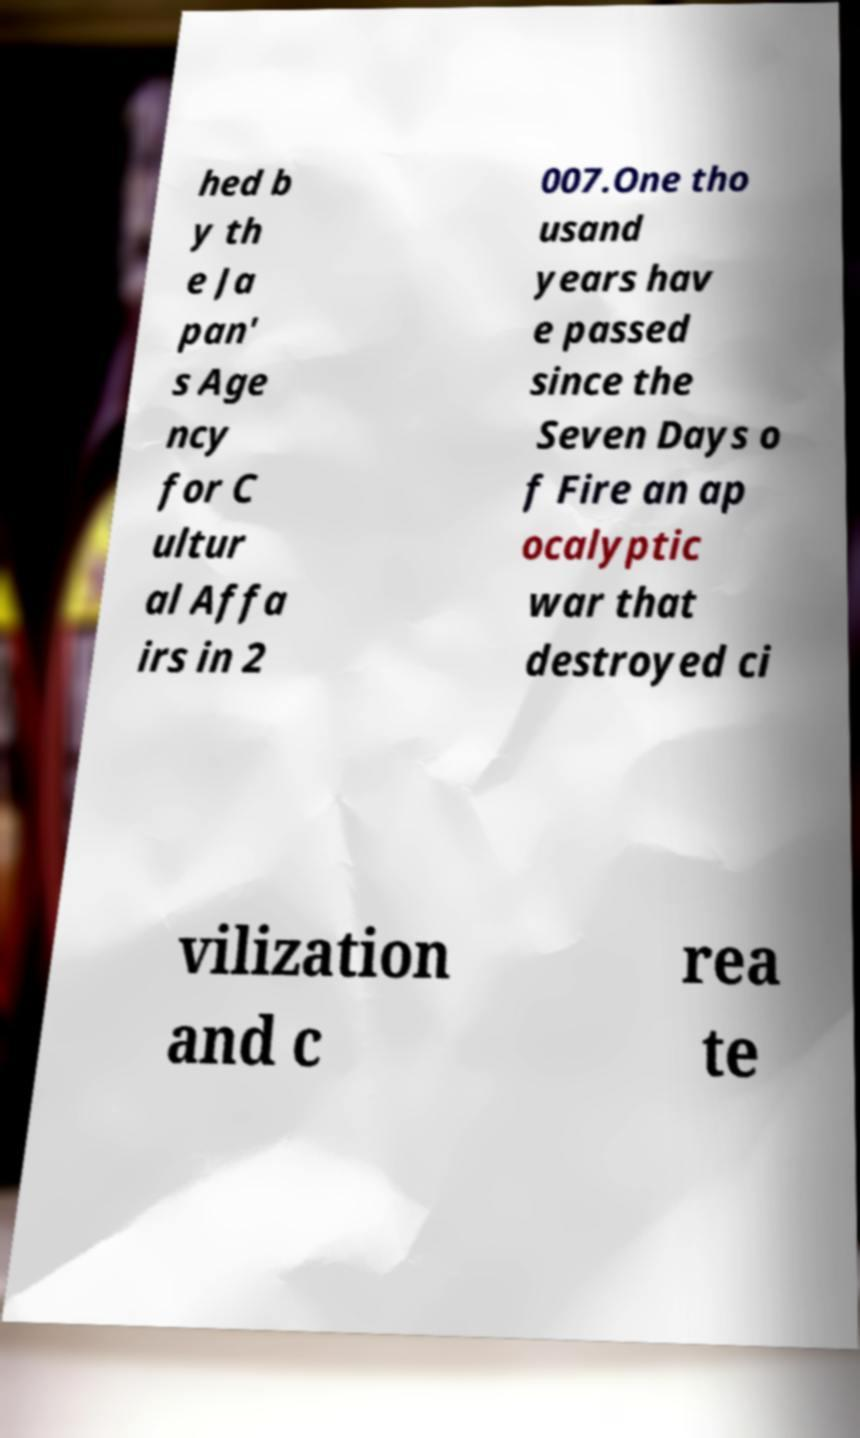Please identify and transcribe the text found in this image. hed b y th e Ja pan' s Age ncy for C ultur al Affa irs in 2 007.One tho usand years hav e passed since the Seven Days o f Fire an ap ocalyptic war that destroyed ci vilization and c rea te 